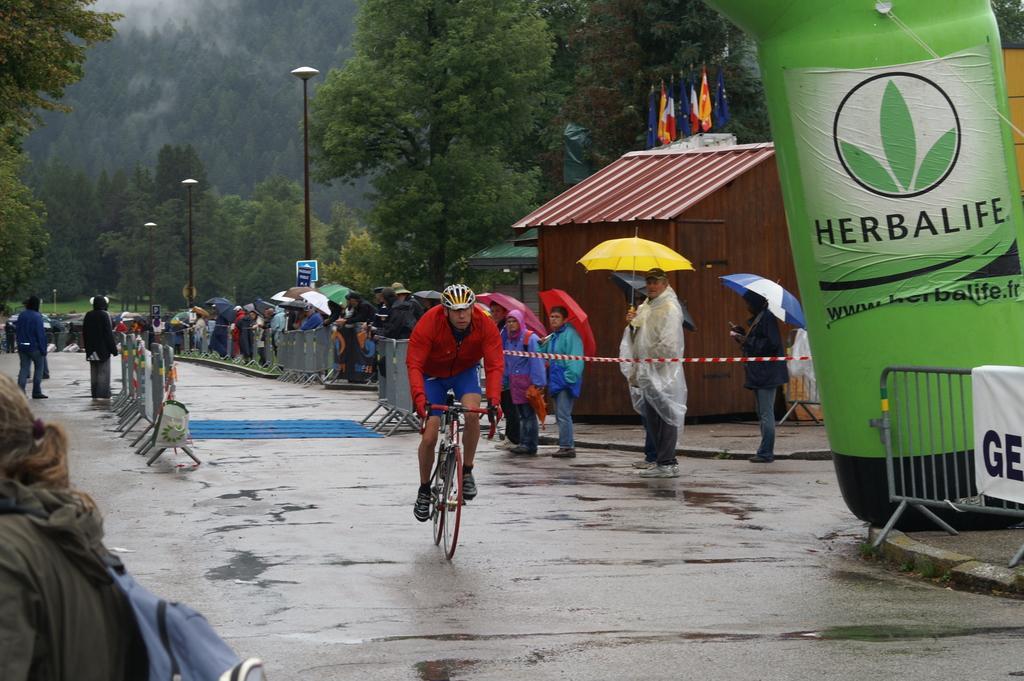Can you describe this image briefly? This picture is clicked outside. In the center there is a person riding a bicycle. On the left we can see the group of persons and some stand placed on the ground. On the right corner there is a green color object and metal rods and we can the group of persons holding umbrellas and standing on the ground. In the background we can see the poles, trees, flags and a cabin. 